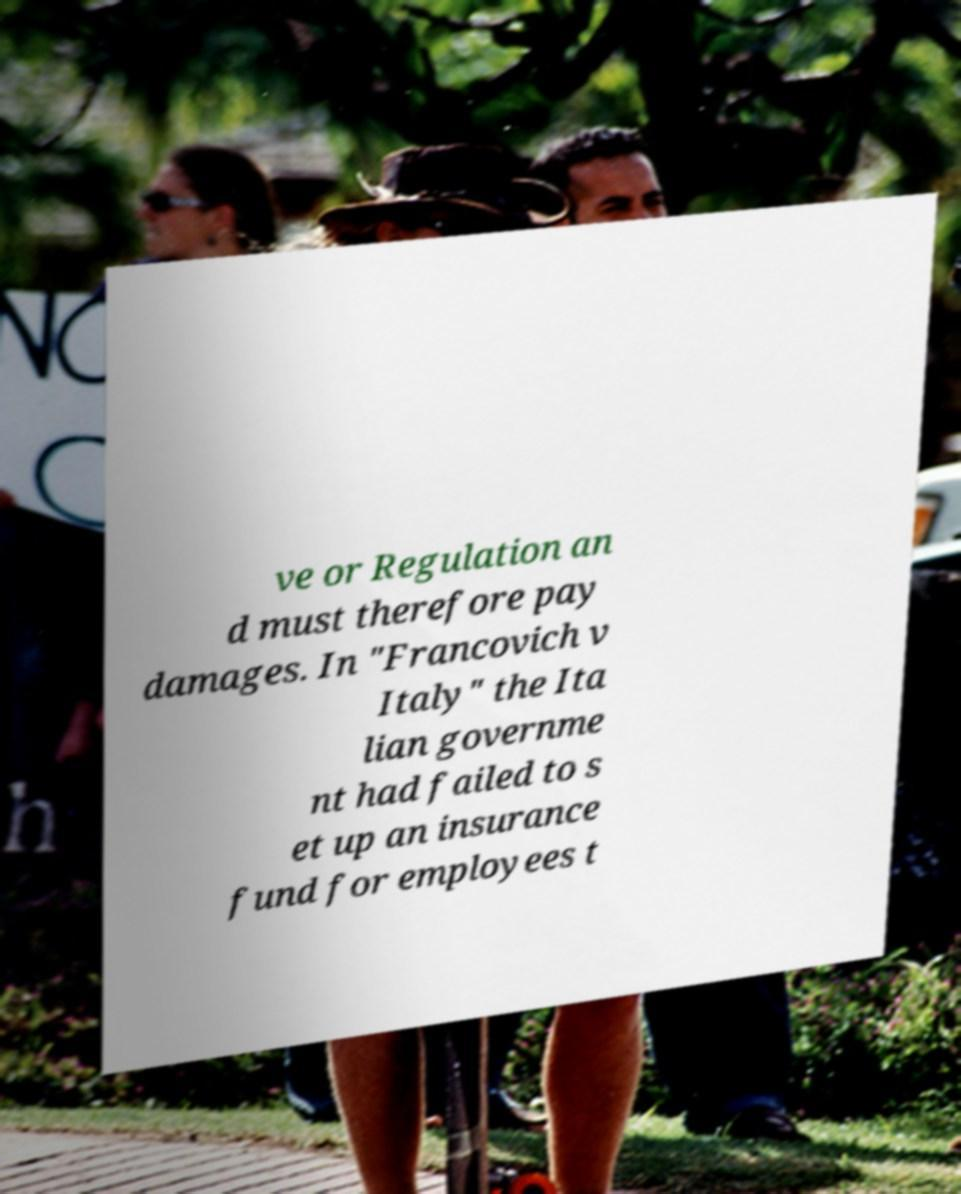I need the written content from this picture converted into text. Can you do that? ve or Regulation an d must therefore pay damages. In "Francovich v Italy" the Ita lian governme nt had failed to s et up an insurance fund for employees t 